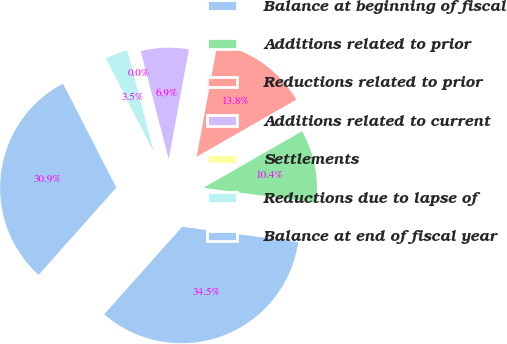Convert chart to OTSL. <chart><loc_0><loc_0><loc_500><loc_500><pie_chart><fcel>Balance at beginning of fiscal<fcel>Additions related to prior<fcel>Reductions related to prior<fcel>Additions related to current<fcel>Settlements<fcel>Reductions due to lapse of<fcel>Balance at end of fiscal year<nl><fcel>34.49%<fcel>10.37%<fcel>13.82%<fcel>6.93%<fcel>0.03%<fcel>3.48%<fcel>30.88%<nl></chart> 